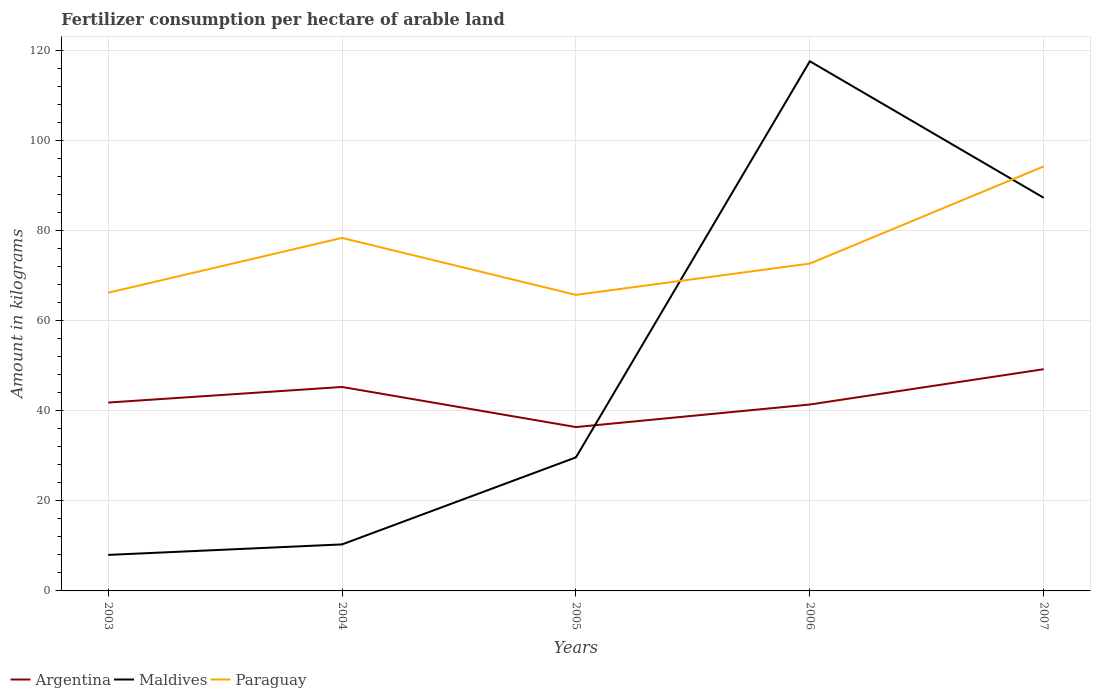How many different coloured lines are there?
Your answer should be very brief. 3. Across all years, what is the maximum amount of fertilizer consumption in Argentina?
Offer a terse response. 36.4. In which year was the amount of fertilizer consumption in Argentina maximum?
Provide a succinct answer. 2005. What is the total amount of fertilizer consumption in Maldives in the graph?
Offer a terse response. -79.33. What is the difference between the highest and the second highest amount of fertilizer consumption in Paraguay?
Your response must be concise. 28.55. What is the difference between the highest and the lowest amount of fertilizer consumption in Maldives?
Give a very brief answer. 2. How many years are there in the graph?
Give a very brief answer. 5. What is the difference between two consecutive major ticks on the Y-axis?
Your response must be concise. 20. Where does the legend appear in the graph?
Your answer should be compact. Bottom left. How many legend labels are there?
Offer a terse response. 3. What is the title of the graph?
Offer a very short reply. Fertilizer consumption per hectare of arable land. What is the label or title of the Y-axis?
Offer a terse response. Amount in kilograms. What is the Amount in kilograms of Argentina in 2003?
Ensure brevity in your answer.  41.85. What is the Amount in kilograms of Paraguay in 2003?
Offer a terse response. 66.24. What is the Amount in kilograms of Argentina in 2004?
Ensure brevity in your answer.  45.31. What is the Amount in kilograms in Maldives in 2004?
Provide a succinct answer. 10.33. What is the Amount in kilograms in Paraguay in 2004?
Your response must be concise. 78.42. What is the Amount in kilograms of Argentina in 2005?
Offer a terse response. 36.4. What is the Amount in kilograms of Maldives in 2005?
Keep it short and to the point. 29.67. What is the Amount in kilograms of Paraguay in 2005?
Provide a short and direct response. 65.76. What is the Amount in kilograms in Argentina in 2006?
Provide a succinct answer. 41.41. What is the Amount in kilograms of Maldives in 2006?
Your response must be concise. 117.67. What is the Amount in kilograms in Paraguay in 2006?
Make the answer very short. 72.72. What is the Amount in kilograms of Argentina in 2007?
Provide a succinct answer. 49.26. What is the Amount in kilograms of Maldives in 2007?
Your response must be concise. 87.33. What is the Amount in kilograms in Paraguay in 2007?
Your answer should be compact. 94.31. Across all years, what is the maximum Amount in kilograms of Argentina?
Provide a short and direct response. 49.26. Across all years, what is the maximum Amount in kilograms of Maldives?
Provide a succinct answer. 117.67. Across all years, what is the maximum Amount in kilograms in Paraguay?
Offer a terse response. 94.31. Across all years, what is the minimum Amount in kilograms of Argentina?
Ensure brevity in your answer.  36.4. Across all years, what is the minimum Amount in kilograms of Paraguay?
Give a very brief answer. 65.76. What is the total Amount in kilograms of Argentina in the graph?
Your response must be concise. 214.23. What is the total Amount in kilograms in Maldives in the graph?
Ensure brevity in your answer.  253. What is the total Amount in kilograms in Paraguay in the graph?
Your answer should be compact. 377.46. What is the difference between the Amount in kilograms in Argentina in 2003 and that in 2004?
Provide a short and direct response. -3.46. What is the difference between the Amount in kilograms in Maldives in 2003 and that in 2004?
Keep it short and to the point. -2.33. What is the difference between the Amount in kilograms in Paraguay in 2003 and that in 2004?
Provide a succinct answer. -12.18. What is the difference between the Amount in kilograms of Argentina in 2003 and that in 2005?
Provide a succinct answer. 5.44. What is the difference between the Amount in kilograms of Maldives in 2003 and that in 2005?
Keep it short and to the point. -21.67. What is the difference between the Amount in kilograms in Paraguay in 2003 and that in 2005?
Ensure brevity in your answer.  0.48. What is the difference between the Amount in kilograms of Argentina in 2003 and that in 2006?
Keep it short and to the point. 0.44. What is the difference between the Amount in kilograms in Maldives in 2003 and that in 2006?
Provide a short and direct response. -109.67. What is the difference between the Amount in kilograms of Paraguay in 2003 and that in 2006?
Make the answer very short. -6.48. What is the difference between the Amount in kilograms in Argentina in 2003 and that in 2007?
Provide a short and direct response. -7.41. What is the difference between the Amount in kilograms in Maldives in 2003 and that in 2007?
Give a very brief answer. -79.33. What is the difference between the Amount in kilograms in Paraguay in 2003 and that in 2007?
Provide a succinct answer. -28.07. What is the difference between the Amount in kilograms in Argentina in 2004 and that in 2005?
Your response must be concise. 8.91. What is the difference between the Amount in kilograms of Maldives in 2004 and that in 2005?
Offer a very short reply. -19.33. What is the difference between the Amount in kilograms of Paraguay in 2004 and that in 2005?
Provide a succinct answer. 12.66. What is the difference between the Amount in kilograms of Argentina in 2004 and that in 2006?
Your answer should be compact. 3.9. What is the difference between the Amount in kilograms of Maldives in 2004 and that in 2006?
Your answer should be very brief. -107.33. What is the difference between the Amount in kilograms in Paraguay in 2004 and that in 2006?
Ensure brevity in your answer.  5.7. What is the difference between the Amount in kilograms in Argentina in 2004 and that in 2007?
Ensure brevity in your answer.  -3.95. What is the difference between the Amount in kilograms of Maldives in 2004 and that in 2007?
Your response must be concise. -77. What is the difference between the Amount in kilograms of Paraguay in 2004 and that in 2007?
Ensure brevity in your answer.  -15.89. What is the difference between the Amount in kilograms in Argentina in 2005 and that in 2006?
Your answer should be compact. -5.01. What is the difference between the Amount in kilograms of Maldives in 2005 and that in 2006?
Offer a very short reply. -88. What is the difference between the Amount in kilograms of Paraguay in 2005 and that in 2006?
Your response must be concise. -6.96. What is the difference between the Amount in kilograms of Argentina in 2005 and that in 2007?
Give a very brief answer. -12.85. What is the difference between the Amount in kilograms of Maldives in 2005 and that in 2007?
Offer a terse response. -57.67. What is the difference between the Amount in kilograms in Paraguay in 2005 and that in 2007?
Your answer should be very brief. -28.55. What is the difference between the Amount in kilograms in Argentina in 2006 and that in 2007?
Give a very brief answer. -7.85. What is the difference between the Amount in kilograms of Maldives in 2006 and that in 2007?
Offer a very short reply. 30.33. What is the difference between the Amount in kilograms of Paraguay in 2006 and that in 2007?
Keep it short and to the point. -21.59. What is the difference between the Amount in kilograms of Argentina in 2003 and the Amount in kilograms of Maldives in 2004?
Your answer should be compact. 31.51. What is the difference between the Amount in kilograms of Argentina in 2003 and the Amount in kilograms of Paraguay in 2004?
Keep it short and to the point. -36.58. What is the difference between the Amount in kilograms of Maldives in 2003 and the Amount in kilograms of Paraguay in 2004?
Provide a succinct answer. -70.42. What is the difference between the Amount in kilograms in Argentina in 2003 and the Amount in kilograms in Maldives in 2005?
Offer a terse response. 12.18. What is the difference between the Amount in kilograms in Argentina in 2003 and the Amount in kilograms in Paraguay in 2005?
Make the answer very short. -23.92. What is the difference between the Amount in kilograms of Maldives in 2003 and the Amount in kilograms of Paraguay in 2005?
Ensure brevity in your answer.  -57.76. What is the difference between the Amount in kilograms of Argentina in 2003 and the Amount in kilograms of Maldives in 2006?
Make the answer very short. -75.82. What is the difference between the Amount in kilograms in Argentina in 2003 and the Amount in kilograms in Paraguay in 2006?
Provide a succinct answer. -30.87. What is the difference between the Amount in kilograms in Maldives in 2003 and the Amount in kilograms in Paraguay in 2006?
Offer a very short reply. -64.72. What is the difference between the Amount in kilograms of Argentina in 2003 and the Amount in kilograms of Maldives in 2007?
Ensure brevity in your answer.  -45.49. What is the difference between the Amount in kilograms in Argentina in 2003 and the Amount in kilograms in Paraguay in 2007?
Provide a succinct answer. -52.46. What is the difference between the Amount in kilograms in Maldives in 2003 and the Amount in kilograms in Paraguay in 2007?
Ensure brevity in your answer.  -86.31. What is the difference between the Amount in kilograms in Argentina in 2004 and the Amount in kilograms in Maldives in 2005?
Give a very brief answer. 15.64. What is the difference between the Amount in kilograms of Argentina in 2004 and the Amount in kilograms of Paraguay in 2005?
Provide a succinct answer. -20.45. What is the difference between the Amount in kilograms of Maldives in 2004 and the Amount in kilograms of Paraguay in 2005?
Keep it short and to the point. -55.43. What is the difference between the Amount in kilograms of Argentina in 2004 and the Amount in kilograms of Maldives in 2006?
Offer a terse response. -72.36. What is the difference between the Amount in kilograms in Argentina in 2004 and the Amount in kilograms in Paraguay in 2006?
Make the answer very short. -27.41. What is the difference between the Amount in kilograms in Maldives in 2004 and the Amount in kilograms in Paraguay in 2006?
Offer a terse response. -62.39. What is the difference between the Amount in kilograms of Argentina in 2004 and the Amount in kilograms of Maldives in 2007?
Make the answer very short. -42.02. What is the difference between the Amount in kilograms of Argentina in 2004 and the Amount in kilograms of Paraguay in 2007?
Provide a succinct answer. -49. What is the difference between the Amount in kilograms of Maldives in 2004 and the Amount in kilograms of Paraguay in 2007?
Give a very brief answer. -83.98. What is the difference between the Amount in kilograms in Argentina in 2005 and the Amount in kilograms in Maldives in 2006?
Your answer should be very brief. -81.26. What is the difference between the Amount in kilograms of Argentina in 2005 and the Amount in kilograms of Paraguay in 2006?
Offer a terse response. -36.32. What is the difference between the Amount in kilograms in Maldives in 2005 and the Amount in kilograms in Paraguay in 2006?
Give a very brief answer. -43.05. What is the difference between the Amount in kilograms in Argentina in 2005 and the Amount in kilograms in Maldives in 2007?
Your answer should be very brief. -50.93. What is the difference between the Amount in kilograms of Argentina in 2005 and the Amount in kilograms of Paraguay in 2007?
Provide a succinct answer. -57.91. What is the difference between the Amount in kilograms in Maldives in 2005 and the Amount in kilograms in Paraguay in 2007?
Provide a short and direct response. -64.64. What is the difference between the Amount in kilograms in Argentina in 2006 and the Amount in kilograms in Maldives in 2007?
Provide a succinct answer. -45.92. What is the difference between the Amount in kilograms in Argentina in 2006 and the Amount in kilograms in Paraguay in 2007?
Provide a succinct answer. -52.9. What is the difference between the Amount in kilograms of Maldives in 2006 and the Amount in kilograms of Paraguay in 2007?
Provide a succinct answer. 23.36. What is the average Amount in kilograms in Argentina per year?
Offer a very short reply. 42.85. What is the average Amount in kilograms of Maldives per year?
Your answer should be very brief. 50.6. What is the average Amount in kilograms in Paraguay per year?
Offer a terse response. 75.49. In the year 2003, what is the difference between the Amount in kilograms in Argentina and Amount in kilograms in Maldives?
Provide a succinct answer. 33.85. In the year 2003, what is the difference between the Amount in kilograms in Argentina and Amount in kilograms in Paraguay?
Your answer should be very brief. -24.39. In the year 2003, what is the difference between the Amount in kilograms of Maldives and Amount in kilograms of Paraguay?
Keep it short and to the point. -58.24. In the year 2004, what is the difference between the Amount in kilograms of Argentina and Amount in kilograms of Maldives?
Your answer should be very brief. 34.98. In the year 2004, what is the difference between the Amount in kilograms of Argentina and Amount in kilograms of Paraguay?
Your answer should be compact. -33.11. In the year 2004, what is the difference between the Amount in kilograms of Maldives and Amount in kilograms of Paraguay?
Your answer should be very brief. -68.09. In the year 2005, what is the difference between the Amount in kilograms in Argentina and Amount in kilograms in Maldives?
Give a very brief answer. 6.74. In the year 2005, what is the difference between the Amount in kilograms of Argentina and Amount in kilograms of Paraguay?
Ensure brevity in your answer.  -29.36. In the year 2005, what is the difference between the Amount in kilograms in Maldives and Amount in kilograms in Paraguay?
Ensure brevity in your answer.  -36.1. In the year 2006, what is the difference between the Amount in kilograms in Argentina and Amount in kilograms in Maldives?
Your answer should be very brief. -76.26. In the year 2006, what is the difference between the Amount in kilograms of Argentina and Amount in kilograms of Paraguay?
Offer a very short reply. -31.31. In the year 2006, what is the difference between the Amount in kilograms of Maldives and Amount in kilograms of Paraguay?
Offer a very short reply. 44.95. In the year 2007, what is the difference between the Amount in kilograms of Argentina and Amount in kilograms of Maldives?
Give a very brief answer. -38.08. In the year 2007, what is the difference between the Amount in kilograms in Argentina and Amount in kilograms in Paraguay?
Keep it short and to the point. -45.05. In the year 2007, what is the difference between the Amount in kilograms of Maldives and Amount in kilograms of Paraguay?
Give a very brief answer. -6.98. What is the ratio of the Amount in kilograms in Argentina in 2003 to that in 2004?
Ensure brevity in your answer.  0.92. What is the ratio of the Amount in kilograms of Maldives in 2003 to that in 2004?
Provide a short and direct response. 0.77. What is the ratio of the Amount in kilograms in Paraguay in 2003 to that in 2004?
Make the answer very short. 0.84. What is the ratio of the Amount in kilograms in Argentina in 2003 to that in 2005?
Make the answer very short. 1.15. What is the ratio of the Amount in kilograms in Maldives in 2003 to that in 2005?
Provide a short and direct response. 0.27. What is the ratio of the Amount in kilograms in Argentina in 2003 to that in 2006?
Provide a short and direct response. 1.01. What is the ratio of the Amount in kilograms in Maldives in 2003 to that in 2006?
Make the answer very short. 0.07. What is the ratio of the Amount in kilograms in Paraguay in 2003 to that in 2006?
Provide a short and direct response. 0.91. What is the ratio of the Amount in kilograms in Argentina in 2003 to that in 2007?
Your response must be concise. 0.85. What is the ratio of the Amount in kilograms of Maldives in 2003 to that in 2007?
Your response must be concise. 0.09. What is the ratio of the Amount in kilograms in Paraguay in 2003 to that in 2007?
Provide a short and direct response. 0.7. What is the ratio of the Amount in kilograms of Argentina in 2004 to that in 2005?
Provide a succinct answer. 1.24. What is the ratio of the Amount in kilograms in Maldives in 2004 to that in 2005?
Offer a terse response. 0.35. What is the ratio of the Amount in kilograms in Paraguay in 2004 to that in 2005?
Provide a short and direct response. 1.19. What is the ratio of the Amount in kilograms in Argentina in 2004 to that in 2006?
Your response must be concise. 1.09. What is the ratio of the Amount in kilograms in Maldives in 2004 to that in 2006?
Offer a very short reply. 0.09. What is the ratio of the Amount in kilograms in Paraguay in 2004 to that in 2006?
Offer a very short reply. 1.08. What is the ratio of the Amount in kilograms of Argentina in 2004 to that in 2007?
Keep it short and to the point. 0.92. What is the ratio of the Amount in kilograms of Maldives in 2004 to that in 2007?
Offer a terse response. 0.12. What is the ratio of the Amount in kilograms of Paraguay in 2004 to that in 2007?
Your answer should be compact. 0.83. What is the ratio of the Amount in kilograms in Argentina in 2005 to that in 2006?
Offer a very short reply. 0.88. What is the ratio of the Amount in kilograms of Maldives in 2005 to that in 2006?
Offer a very short reply. 0.25. What is the ratio of the Amount in kilograms of Paraguay in 2005 to that in 2006?
Provide a short and direct response. 0.9. What is the ratio of the Amount in kilograms of Argentina in 2005 to that in 2007?
Offer a terse response. 0.74. What is the ratio of the Amount in kilograms of Maldives in 2005 to that in 2007?
Ensure brevity in your answer.  0.34. What is the ratio of the Amount in kilograms of Paraguay in 2005 to that in 2007?
Your answer should be very brief. 0.7. What is the ratio of the Amount in kilograms in Argentina in 2006 to that in 2007?
Provide a succinct answer. 0.84. What is the ratio of the Amount in kilograms of Maldives in 2006 to that in 2007?
Keep it short and to the point. 1.35. What is the ratio of the Amount in kilograms in Paraguay in 2006 to that in 2007?
Give a very brief answer. 0.77. What is the difference between the highest and the second highest Amount in kilograms of Argentina?
Give a very brief answer. 3.95. What is the difference between the highest and the second highest Amount in kilograms of Maldives?
Offer a very short reply. 30.33. What is the difference between the highest and the second highest Amount in kilograms in Paraguay?
Make the answer very short. 15.89. What is the difference between the highest and the lowest Amount in kilograms in Argentina?
Offer a terse response. 12.85. What is the difference between the highest and the lowest Amount in kilograms of Maldives?
Give a very brief answer. 109.67. What is the difference between the highest and the lowest Amount in kilograms in Paraguay?
Provide a short and direct response. 28.55. 